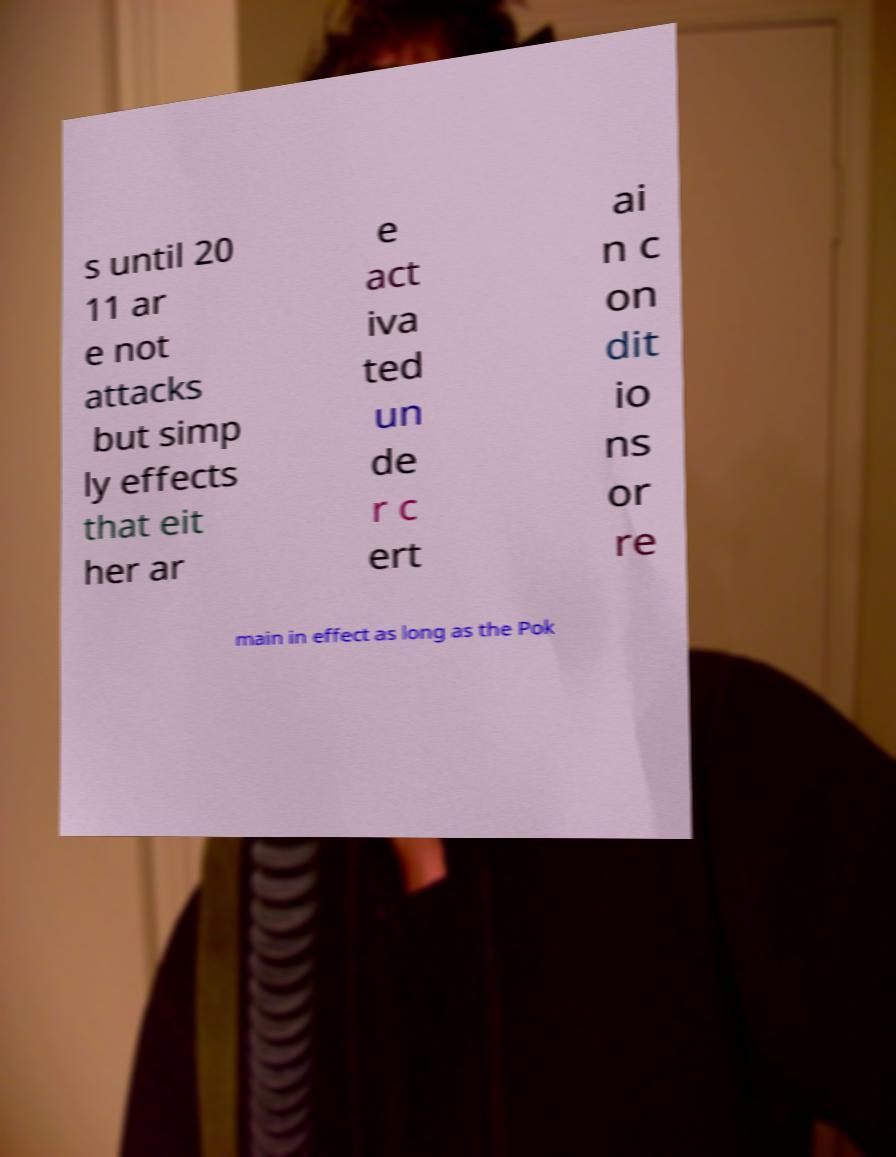Can you read and provide the text displayed in the image?This photo seems to have some interesting text. Can you extract and type it out for me? s until 20 11 ar e not attacks but simp ly effects that eit her ar e act iva ted un de r c ert ai n c on dit io ns or re main in effect as long as the Pok 